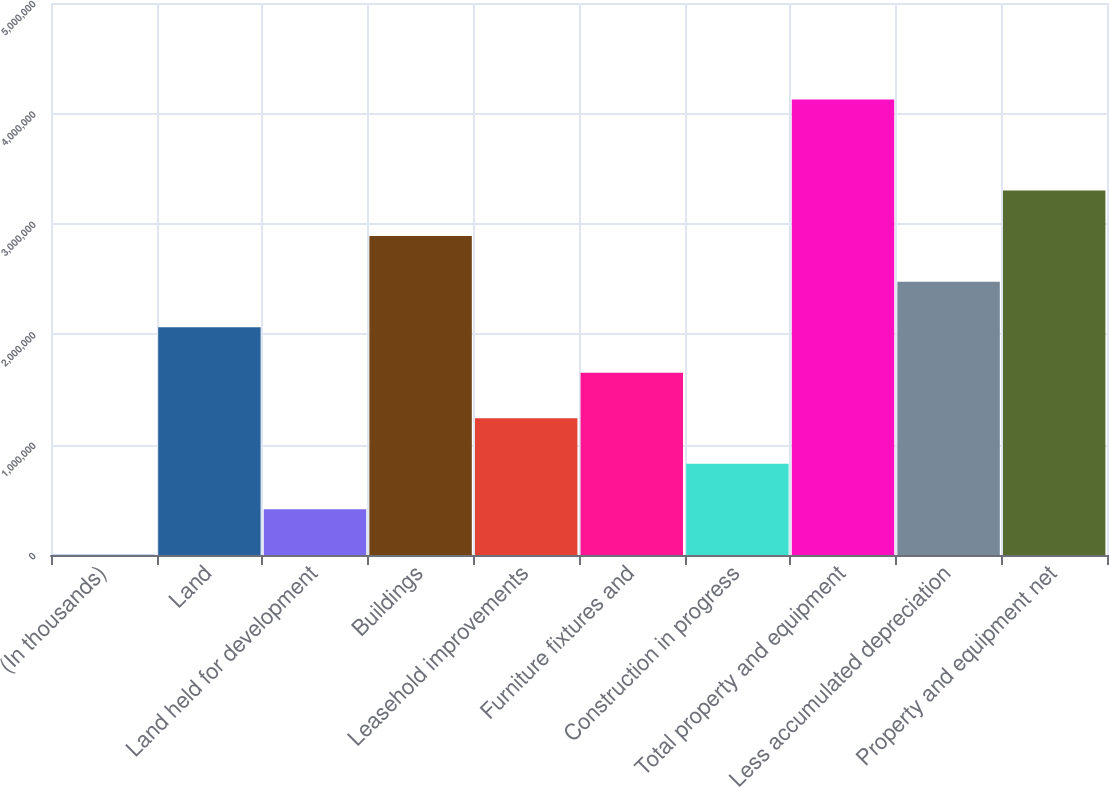Convert chart to OTSL. <chart><loc_0><loc_0><loc_500><loc_500><bar_chart><fcel>(In thousands)<fcel>Land<fcel>Land held for development<fcel>Buildings<fcel>Leasehold improvements<fcel>Furniture fixtures and<fcel>Construction in progress<fcel>Total property and equipment<fcel>Less accumulated depreciation<fcel>Property and equipment net<nl><fcel>2019<fcel>2.06374e+06<fcel>414362<fcel>2.88842e+06<fcel>1.23905e+06<fcel>1.65139e+06<fcel>826705<fcel>4.12545e+06<fcel>2.47608e+06<fcel>3.30076e+06<nl></chart> 